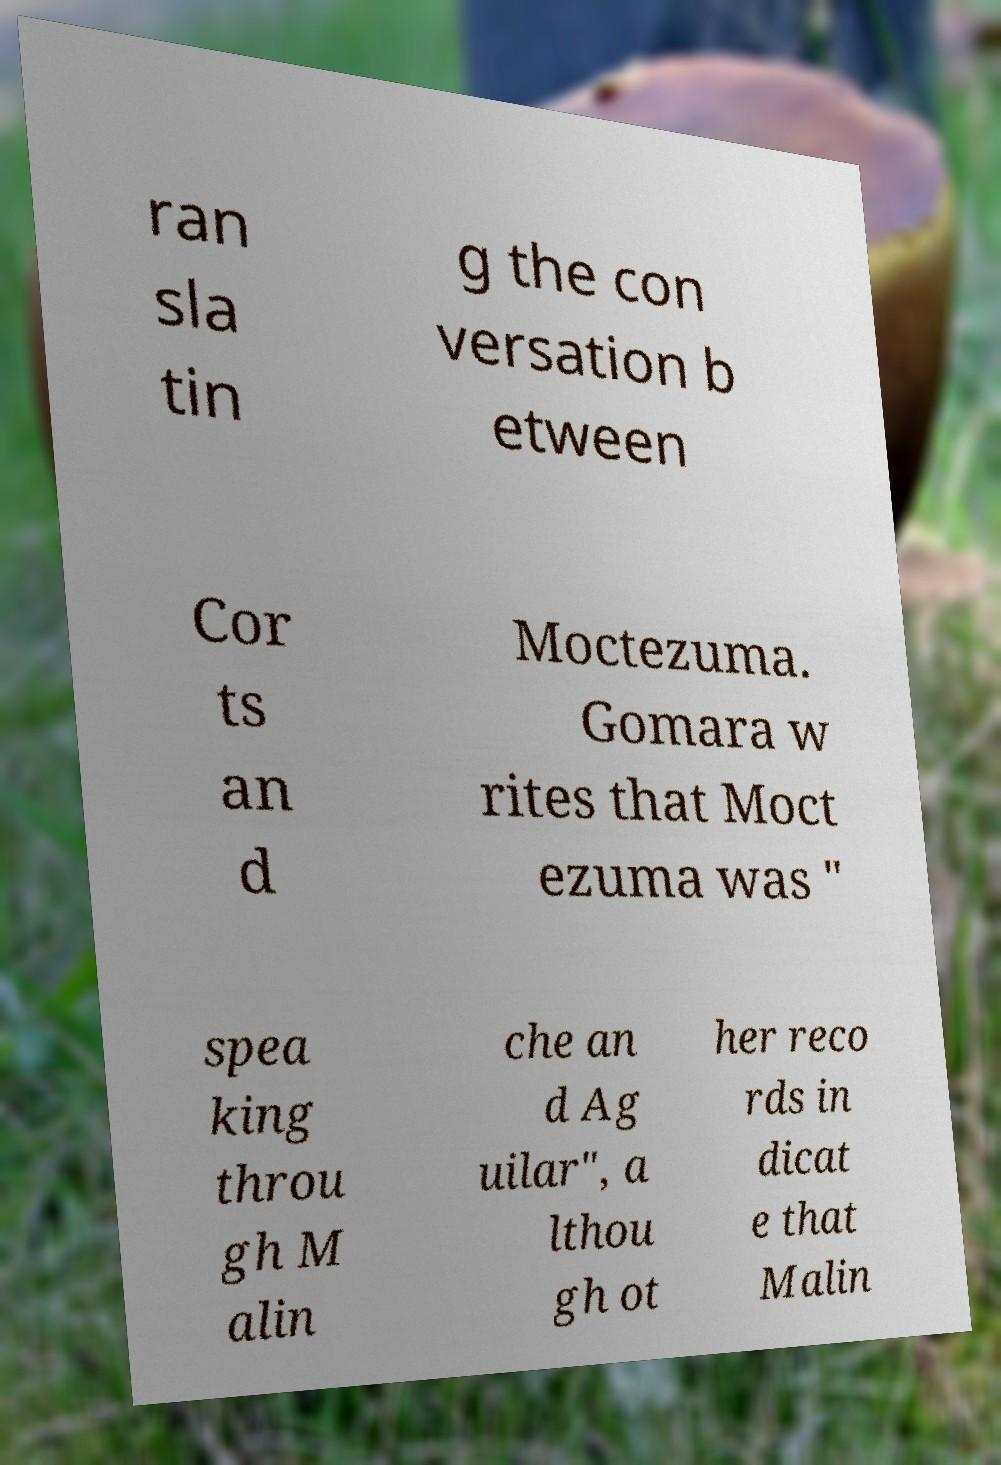Can you accurately transcribe the text from the provided image for me? ran sla tin g the con versation b etween Cor ts an d Moctezuma. Gomara w rites that Moct ezuma was " spea king throu gh M alin che an d Ag uilar", a lthou gh ot her reco rds in dicat e that Malin 